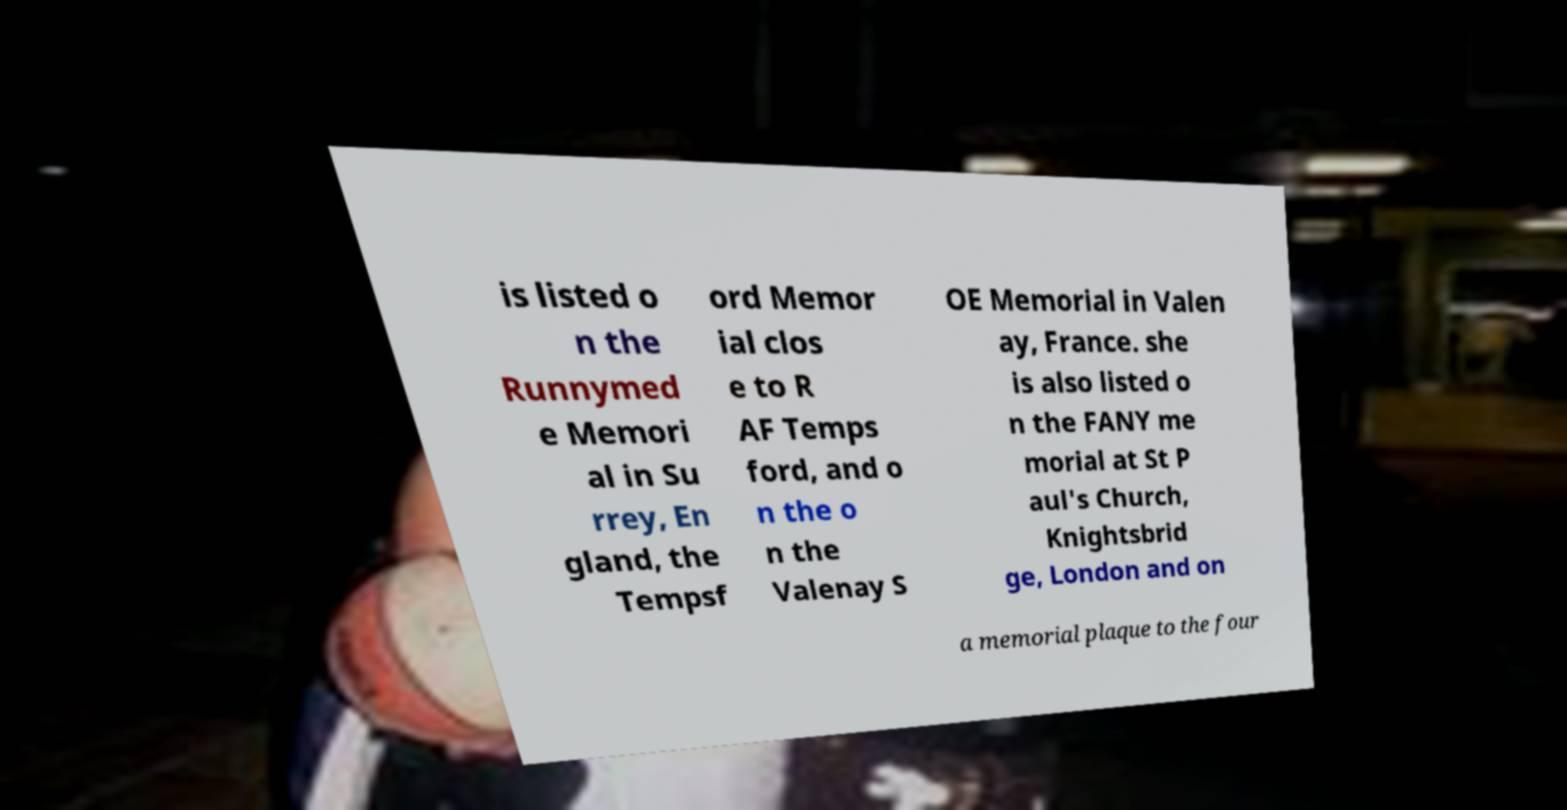What messages or text are displayed in this image? I need them in a readable, typed format. is listed o n the Runnymed e Memori al in Su rrey, En gland, the Tempsf ord Memor ial clos e to R AF Temps ford, and o n the o n the Valenay S OE Memorial in Valen ay, France. she is also listed o n the FANY me morial at St P aul's Church, Knightsbrid ge, London and on a memorial plaque to the four 